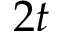Convert formula to latex. <formula><loc_0><loc_0><loc_500><loc_500>2 t</formula> 